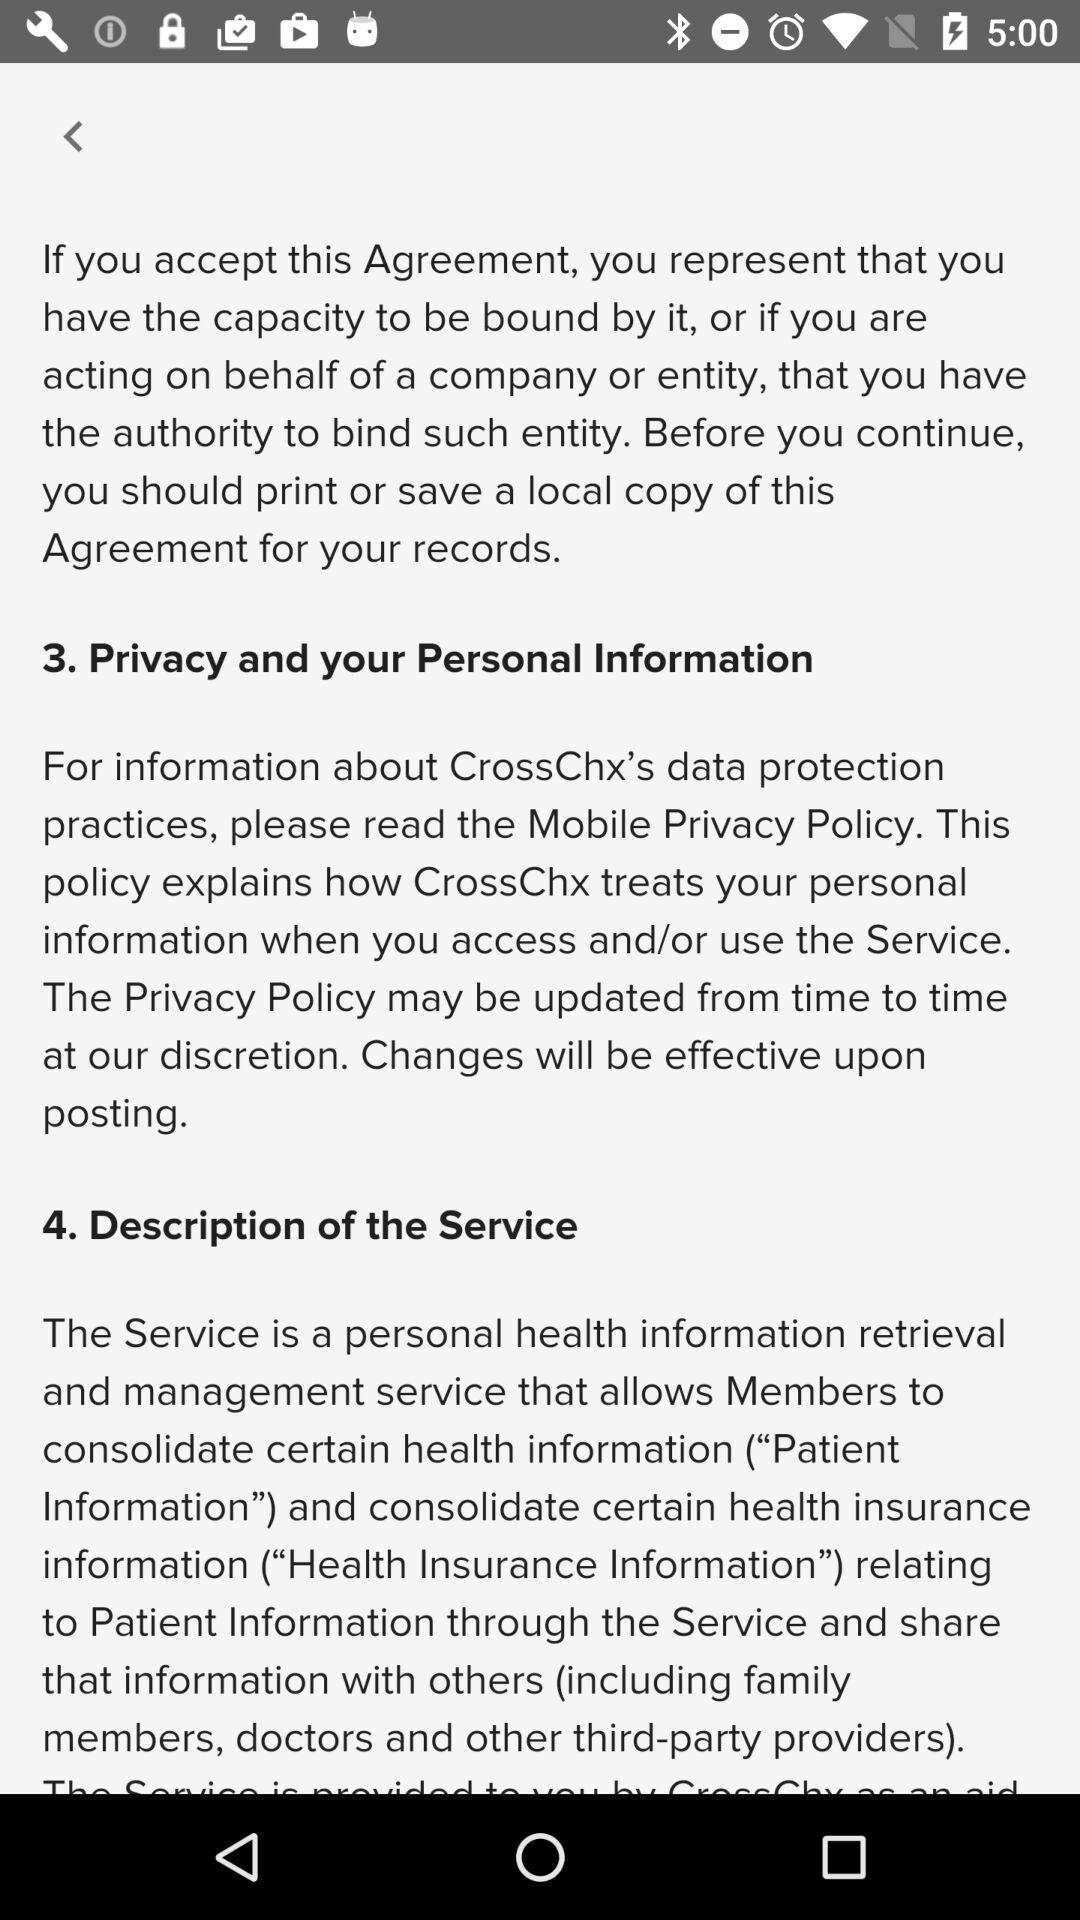How many sections are there in the agreement?
Answer the question using a single word or phrase. 4 